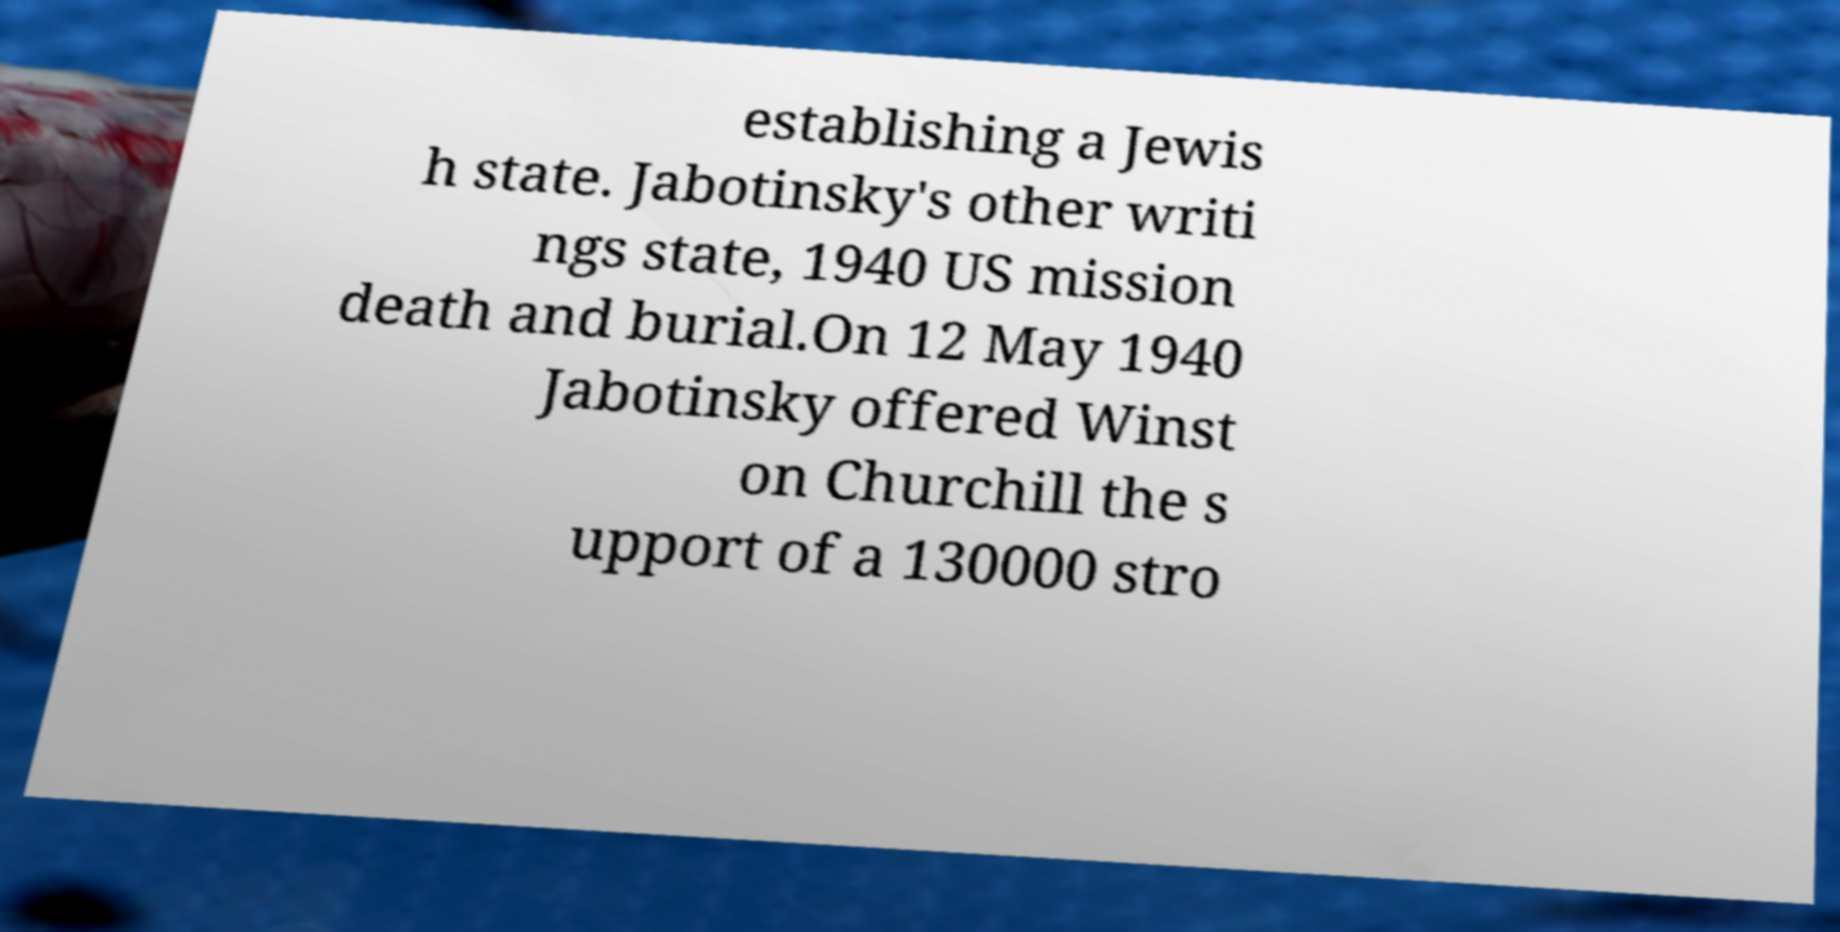Could you assist in decoding the text presented in this image and type it out clearly? establishing a Jewis h state. Jabotinsky's other writi ngs state, 1940 US mission death and burial.On 12 May 1940 Jabotinsky offered Winst on Churchill the s upport of a 130000 stro 